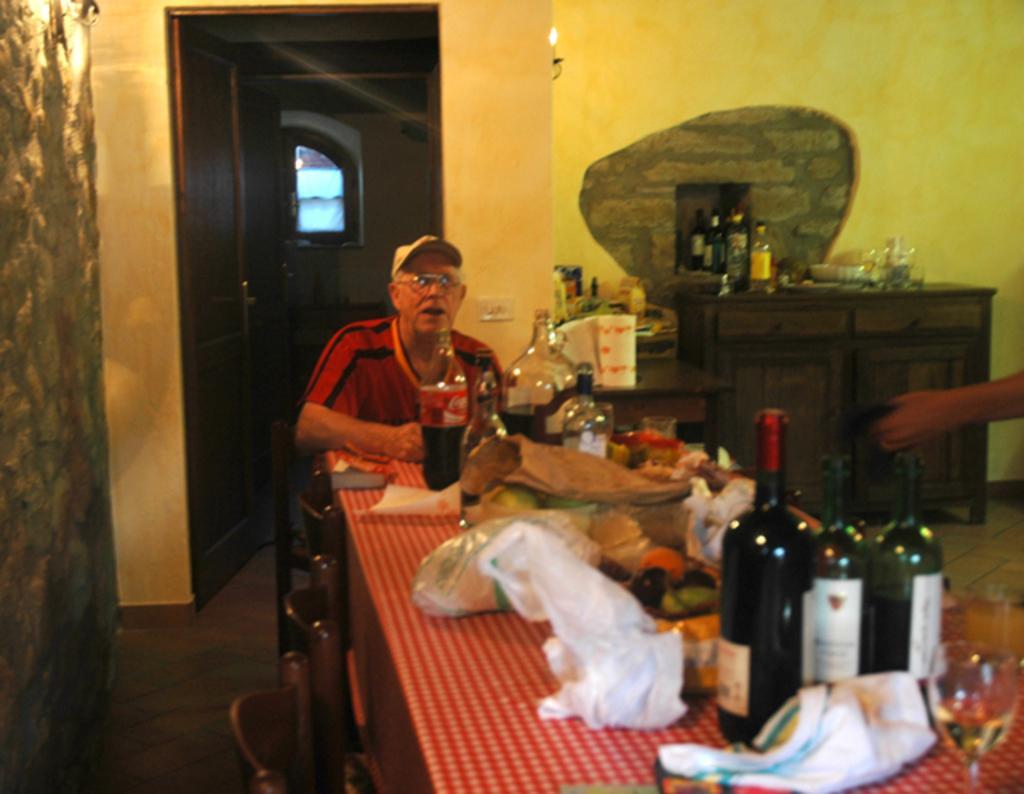How would you summarize this image in a sentence or two? In this image I see a man who is in front of a table and there are lot of bottles and other things on it. In the background I see the wall and a drawer over here and there are few bottles on it too. 